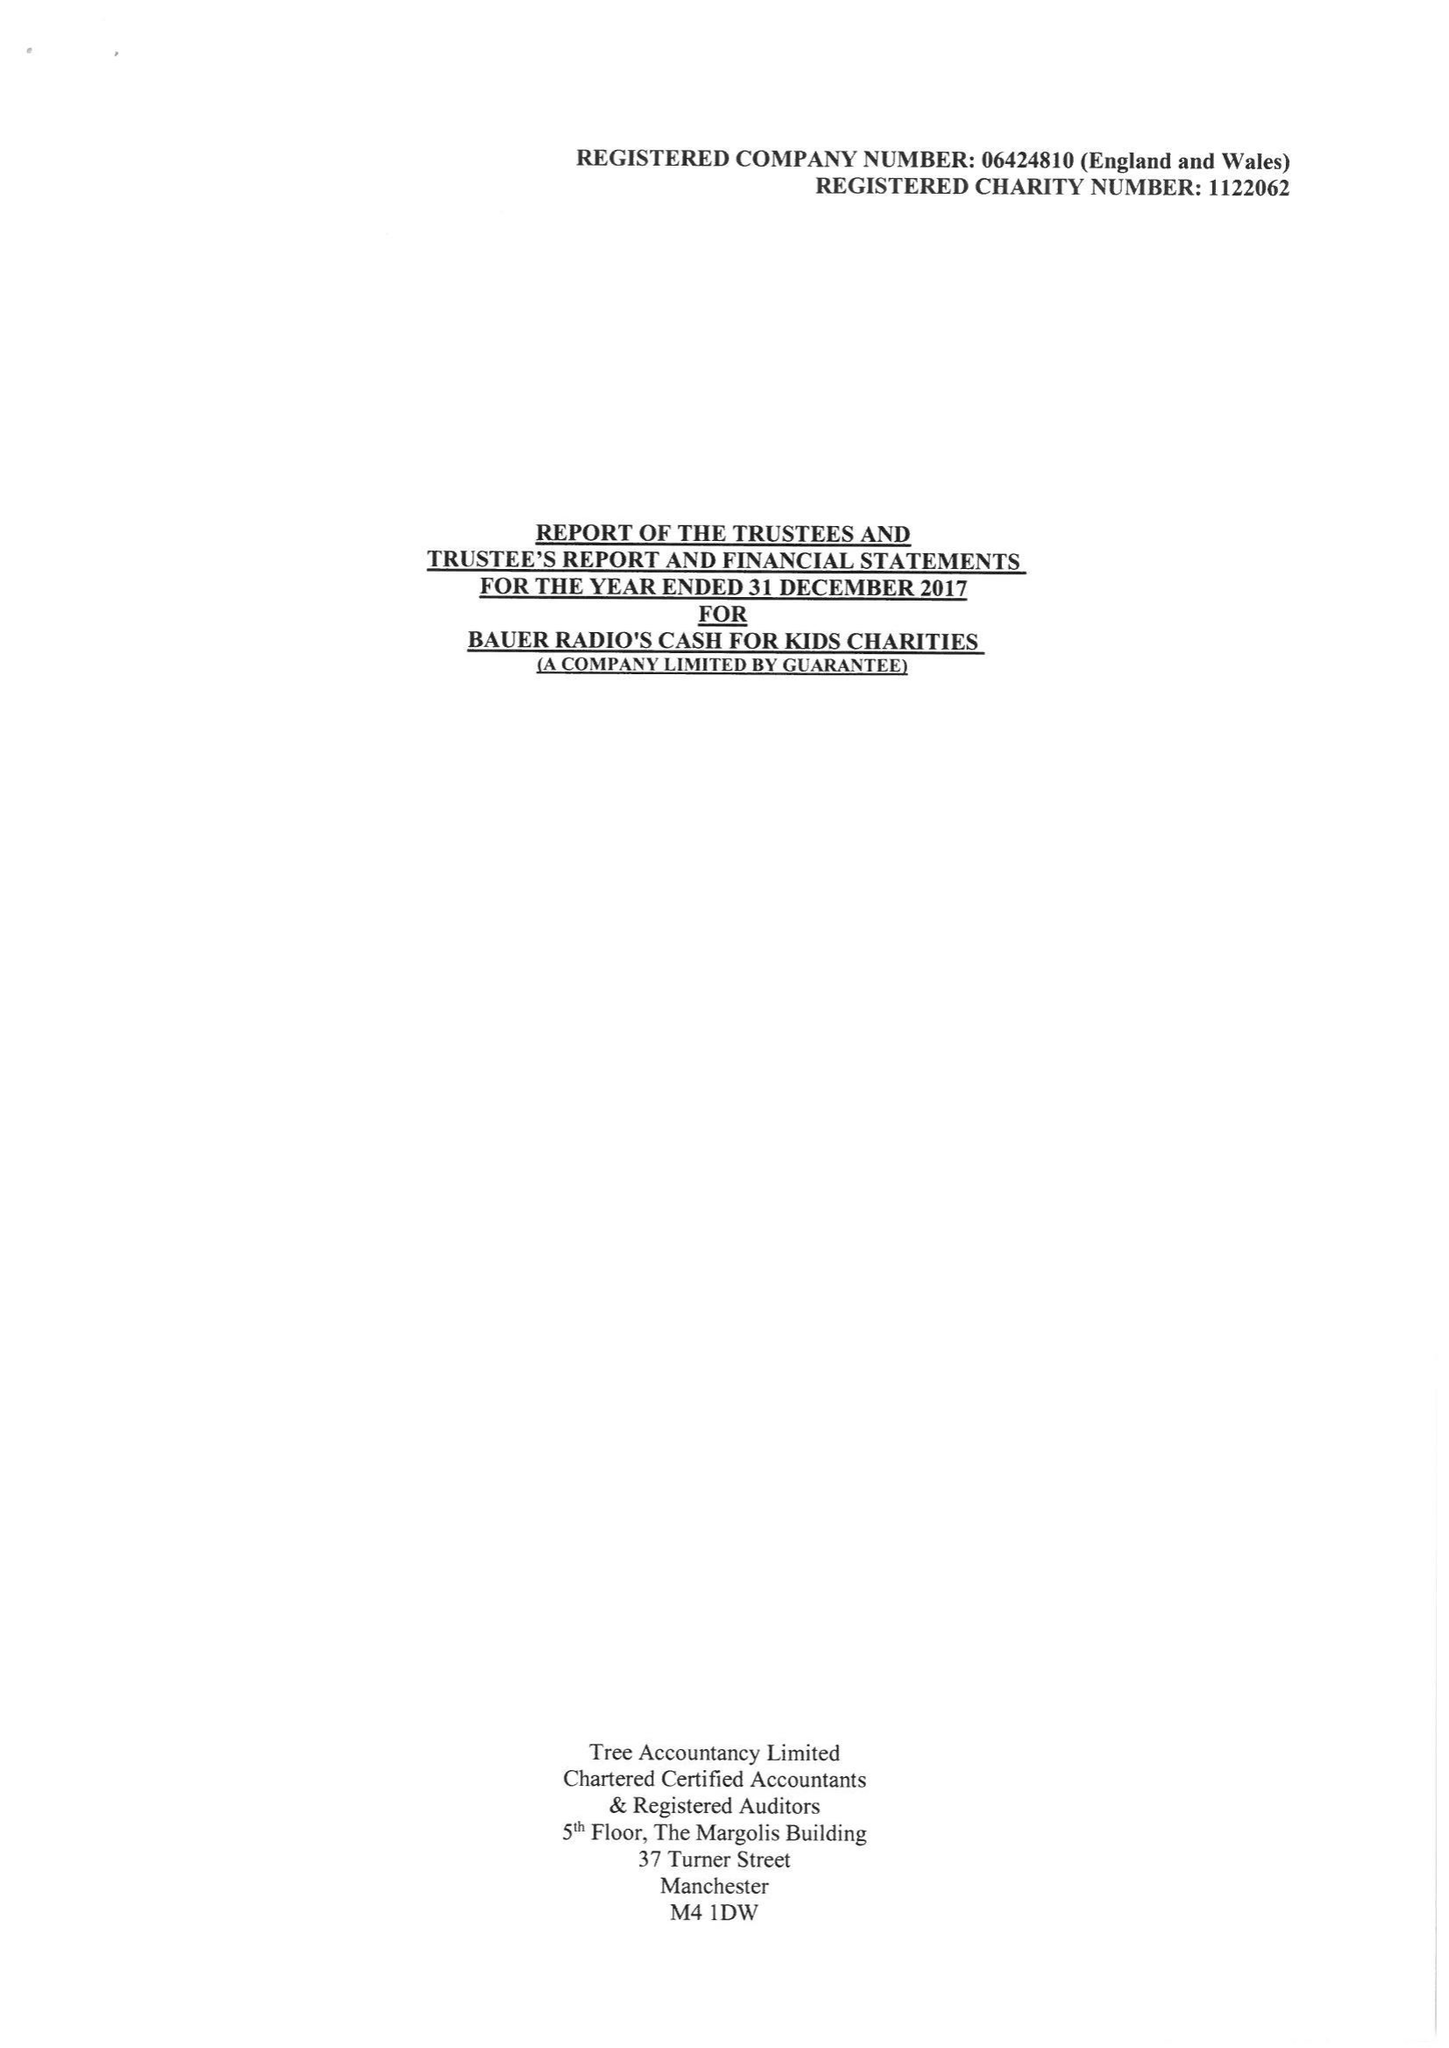What is the value for the address__postcode?
Answer the question using a single word or phrase. TS18 3TS 